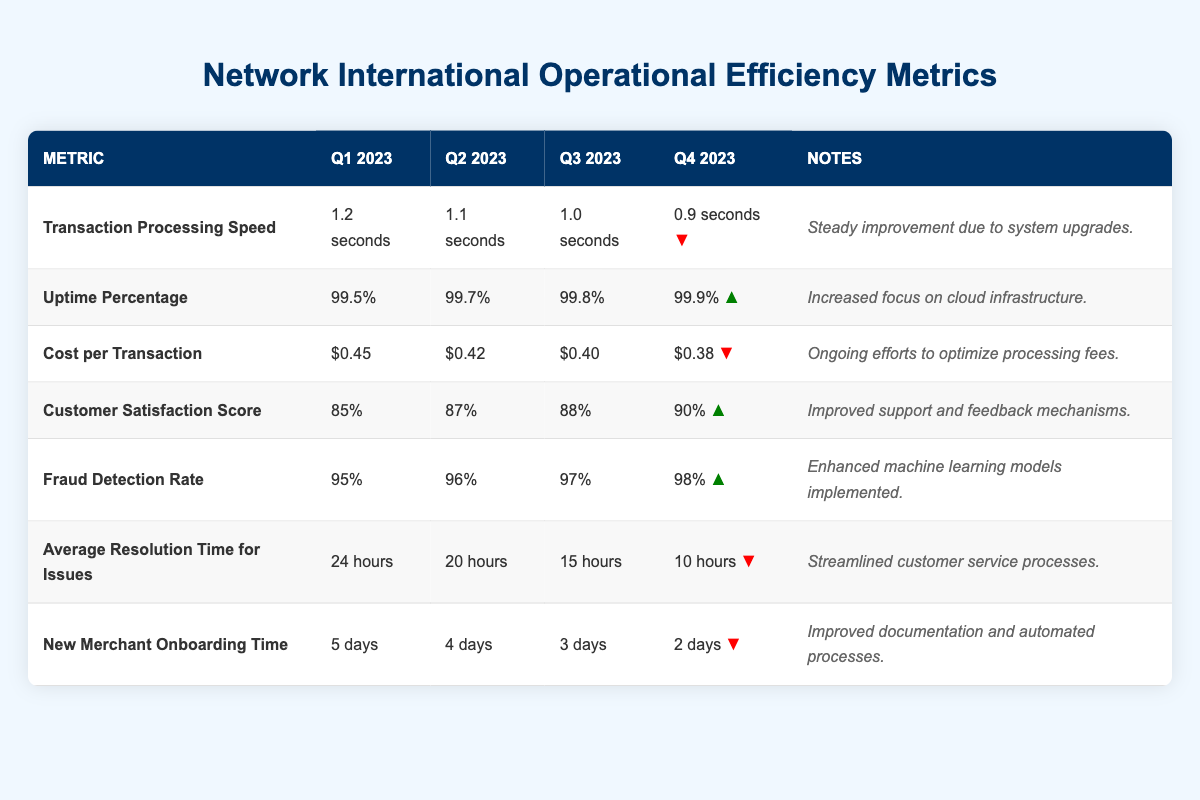What was the transaction processing speed in Q4 2023? The table shows the transaction processing speed for each quarter, which lists Q4 2023 as "0.9 seconds."
Answer: 0.9 seconds How did the uptime percentage change from Q1 2023 to Q4 2023? The uptime percentage was 99.5% in Q1 2023 and increased to 99.9% in Q4 2023, showing a difference of 0.4%.
Answer: Increased by 0.4% What was the cost per transaction in Q3 2023? In the table, the cost per transaction for Q3 2023 is listed as "$0.40."
Answer: $0.40 True or false: The average resolution time for issues improved from Q1 2023 to Q4 2023. In Q1 2023, the average resolution time was 24 hours and decreased to 10 hours in Q4 2023, indicating improvement.
Answer: True What is the average customer satisfaction score during 2023? The scores for customer satisfaction are 85%, 87%, 88%, and 90%. Adding these gives 350%. Dividing by 4 results in an average of 87.5%.
Answer: 87.5% Which metric showed the greatest improvement over the year? Transaction processing speed went from 1.2 seconds to 0.9 seconds, an improvement of 0.3 seconds. Uptime percentage improved from 99.5% to 99.9%, which is a 0.4% improvement. However, the greatest absolute improvement is in "Average Resolution Time for Issues," from 24 hours to 10 hours (14 hours).
Answer: Average Resolution Time for Issues What was the change in fraud detection rate from Q2 2023 to Q4 2023? The fraud detection rate was 96% in Q2 2023 and increased to 98% in Q4 2023, showing a change of 2%.
Answer: Increased by 2% What is the trend for new merchant onboarding time throughout the year? The new merchant onboarding time decreased from 5 days in Q1 2023 to 2 days in Q4 2023, indicating a consistent downward trend over the year.
Answer: Decreased consistently How does the Q4 2023 customer satisfaction score compare to Q1 2023? The customer satisfaction score was 85% in Q1 2023 and rose to 90% in Q4 2023, indicating a 5% increase over the year.
Answer: Increased by 5% What was the overall trend in cost per transaction from Q1 to Q4 2023? The cost per transaction decreased from $0.45 in Q1 to $0.38 in Q4, indicating a downward trend of $0.07.
Answer: Decreased by $0.07 